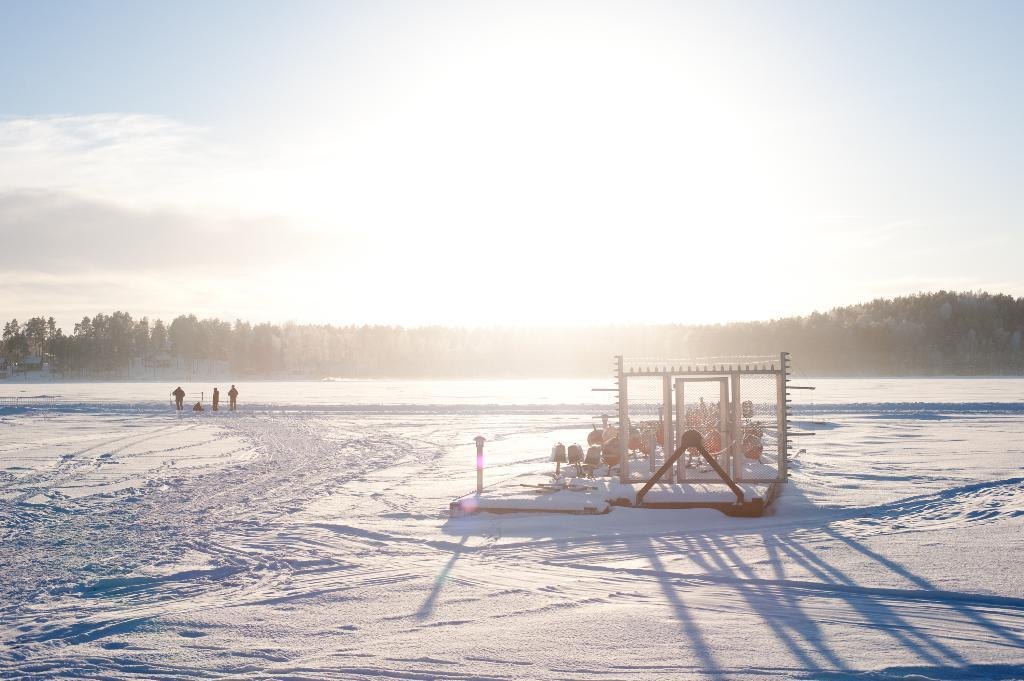What is the surface on which the people are standing in the image? The people are standing on the snow in the image. What else can be seen on the snow besides the people? There are objects on the snow in the image. What can be seen in the background of the image? There are trees, the sun, and the sky visible in the background of the image. What type of print can be seen on the girls' clothing in the image? There are no girls present in the image, so it is not possible to determine what type of print might be on their clothing. 